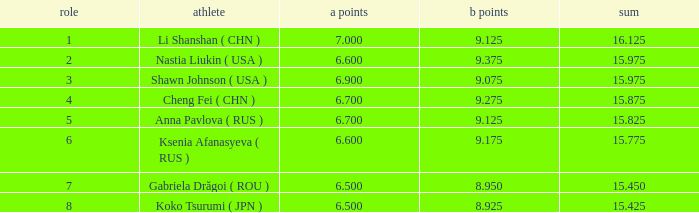What's the total that the position is less than 1? None. 